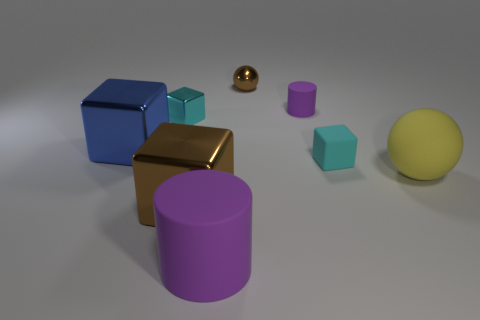There is a brown shiny ball; how many cylinders are to the right of it?
Give a very brief answer. 1. There is a rubber cylinder that is behind the large block in front of the tiny cyan rubber thing; how big is it?
Offer a very short reply. Small. There is a brown metal thing on the right side of the brown metallic cube; does it have the same shape as the big rubber thing that is behind the big purple cylinder?
Your response must be concise. Yes. The brown metallic thing that is behind the sphere that is in front of the large blue thing is what shape?
Ensure brevity in your answer.  Sphere. There is a thing that is both in front of the yellow thing and to the right of the big brown shiny object; how big is it?
Keep it short and to the point. Large. There is a large blue thing; is its shape the same as the small cyan thing on the right side of the big purple cylinder?
Keep it short and to the point. Yes. The cyan rubber object that is the same shape as the big blue metallic thing is what size?
Provide a succinct answer. Small. There is a large cylinder; is it the same color as the cube that is behind the large blue metallic object?
Make the answer very short. No. The purple object right of the matte cylinder in front of the purple cylinder that is right of the large matte cylinder is what shape?
Your response must be concise. Cylinder. Is the size of the rubber cube the same as the purple object that is in front of the rubber cube?
Offer a terse response. No. 